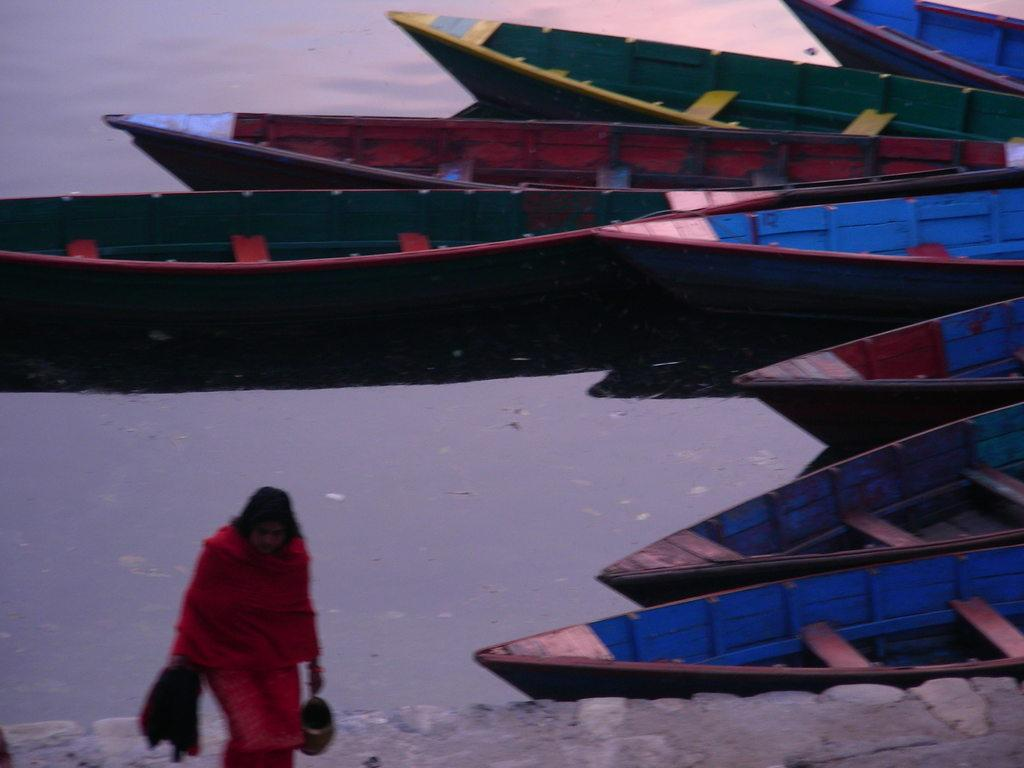What is the primary subject of the image? The primary subject of the image is many boats on a lake. Where are the boats located in the image? The boats are on a lake. Can you describe the woman in the image? There is a woman walking in the image, and she is on the left side. What type of shock can be seen affecting the chin of the woman in the image? There is no shock or any reference to a chin in the image; it features boats on a lake and a woman walking. 